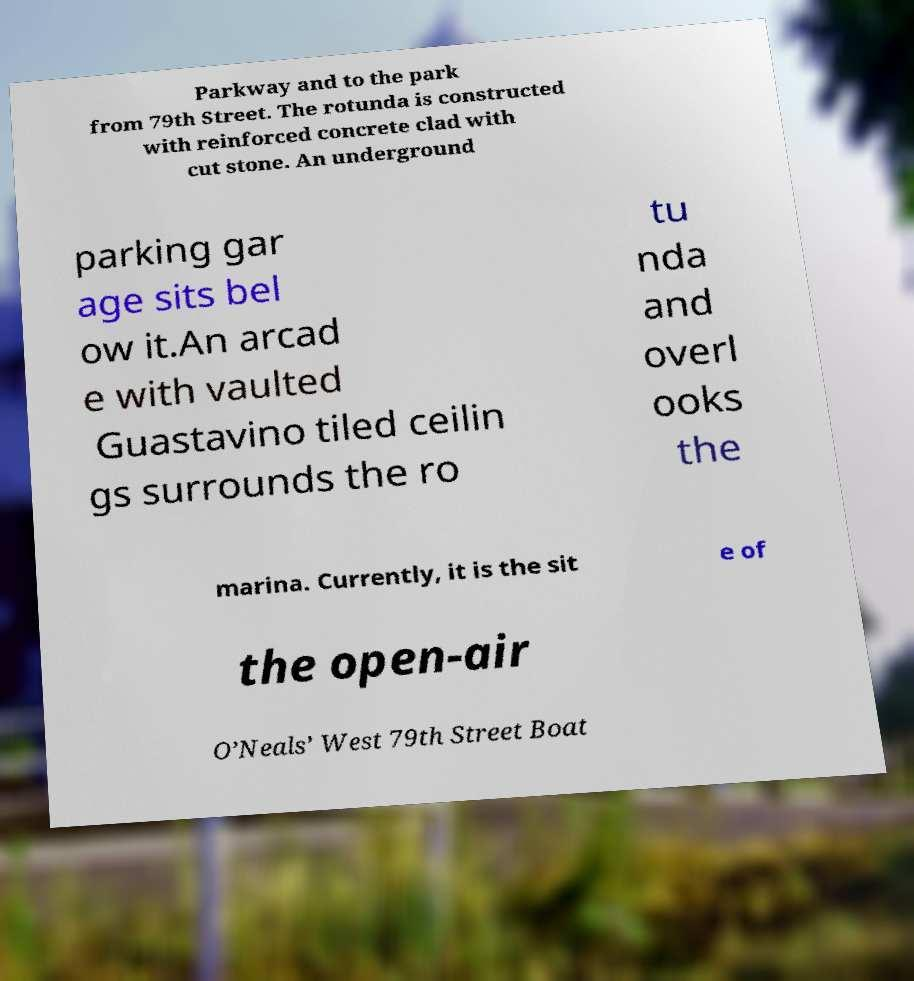What messages or text are displayed in this image? I need them in a readable, typed format. Parkway and to the park from 79th Street. The rotunda is constructed with reinforced concrete clad with cut stone. An underground parking gar age sits bel ow it.An arcad e with vaulted Guastavino tiled ceilin gs surrounds the ro tu nda and overl ooks the marina. Currently, it is the sit e of the open-air O’Neals’ West 79th Street Boat 